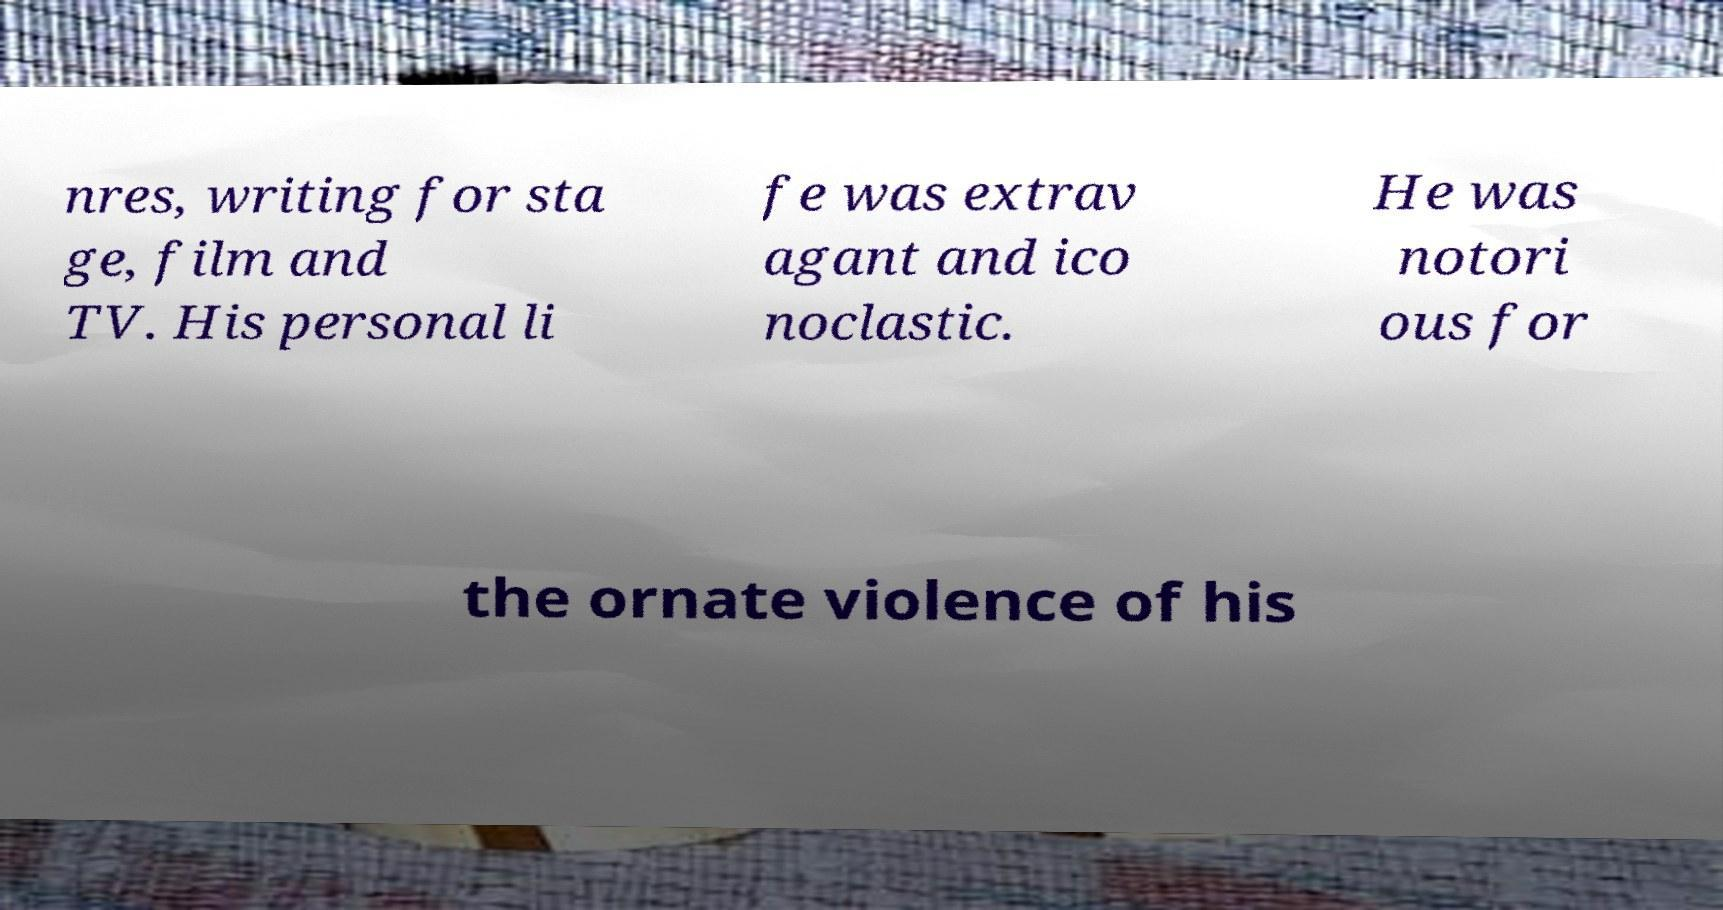Can you read and provide the text displayed in the image?This photo seems to have some interesting text. Can you extract and type it out for me? nres, writing for sta ge, film and TV. His personal li fe was extrav agant and ico noclastic. He was notori ous for the ornate violence of his 